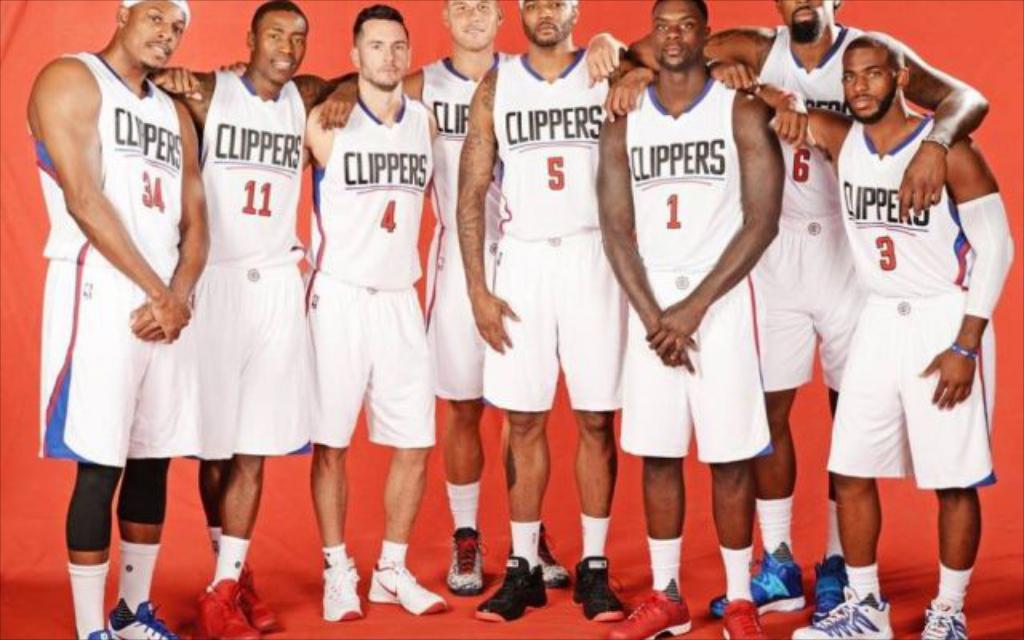<image>
Relay a brief, clear account of the picture shown. the name Clippers is on the jersey of a player 